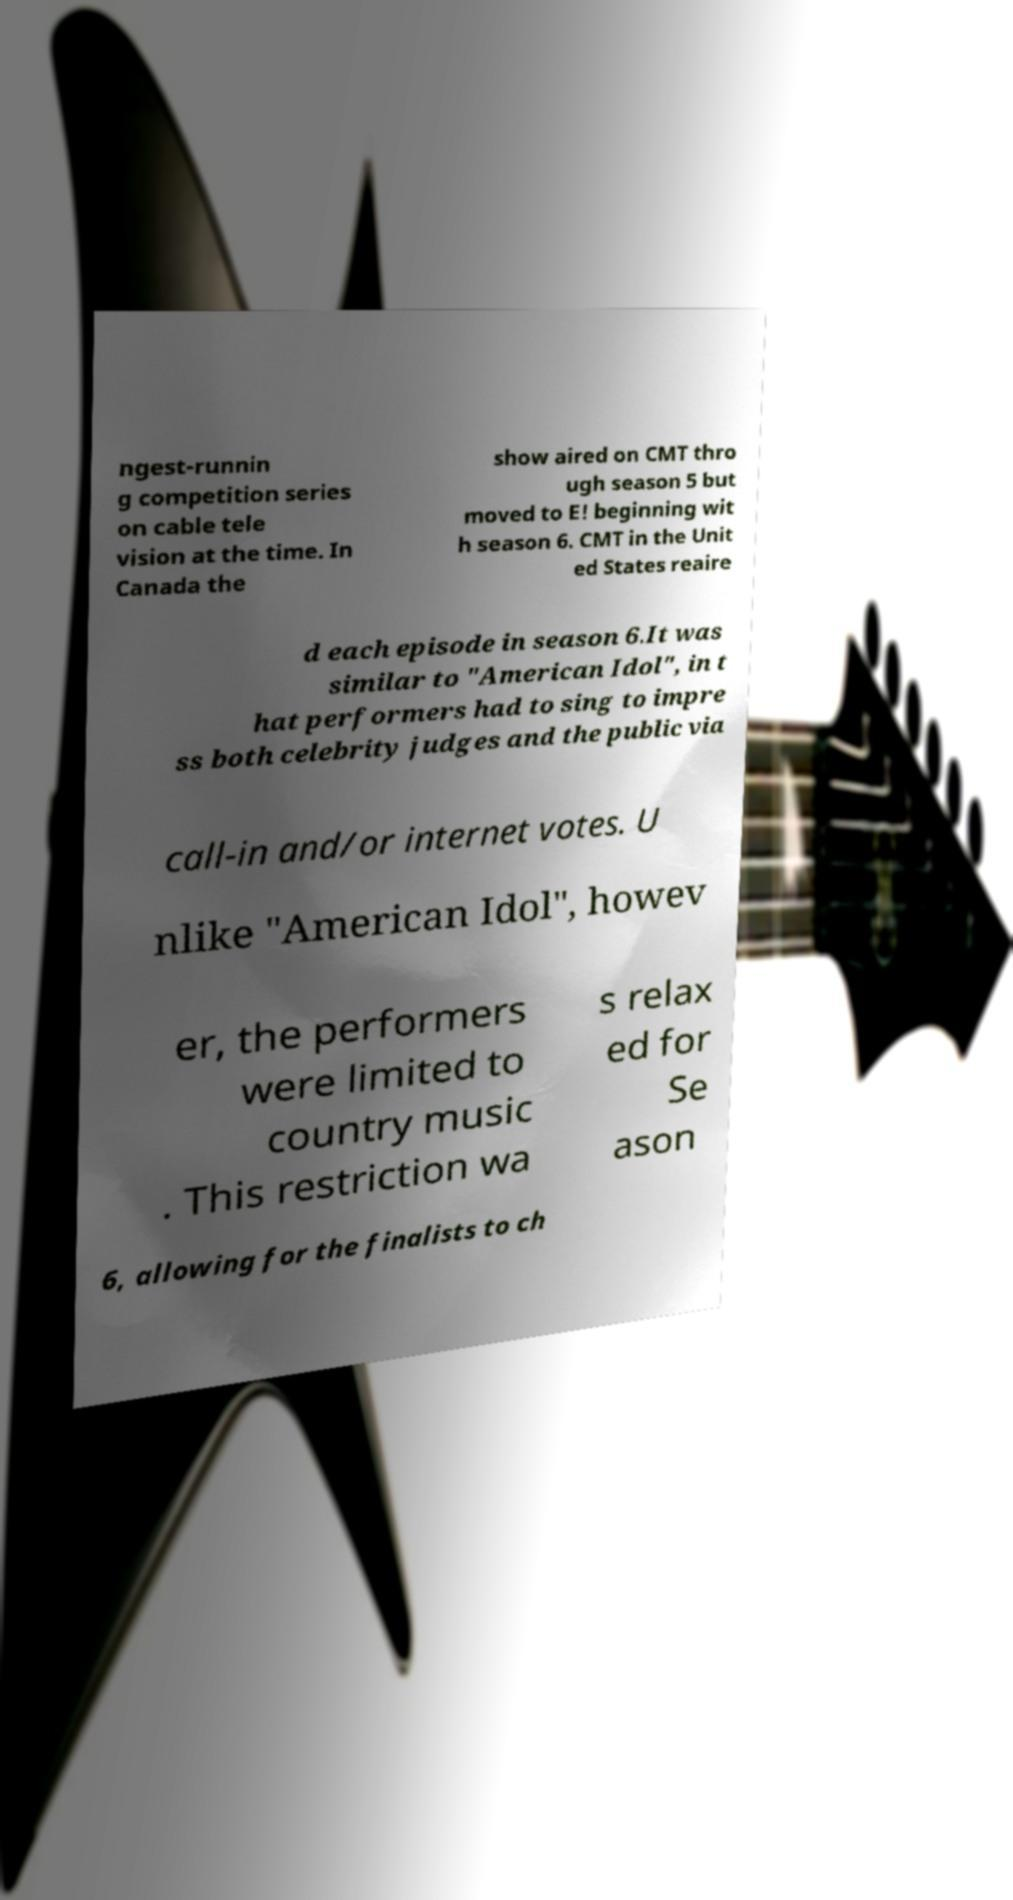Please identify and transcribe the text found in this image. ngest-runnin g competition series on cable tele vision at the time. In Canada the show aired on CMT thro ugh season 5 but moved to E! beginning wit h season 6. CMT in the Unit ed States reaire d each episode in season 6.It was similar to "American Idol", in t hat performers had to sing to impre ss both celebrity judges and the public via call-in and/or internet votes. U nlike "American Idol", howev er, the performers were limited to country music . This restriction wa s relax ed for Se ason 6, allowing for the finalists to ch 